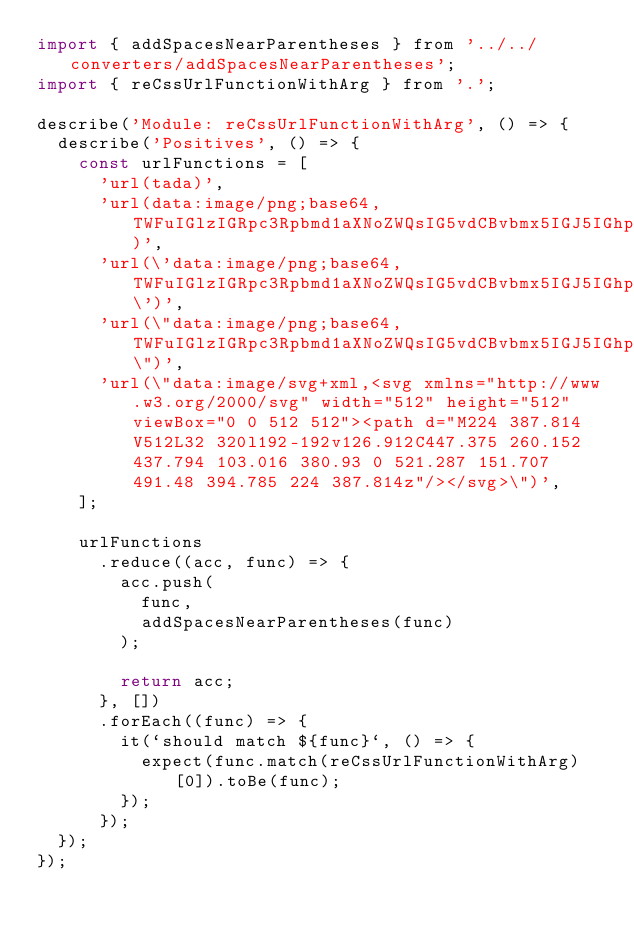Convert code to text. <code><loc_0><loc_0><loc_500><loc_500><_JavaScript_>import { addSpacesNearParentheses } from '../../converters/addSpacesNearParentheses';
import { reCssUrlFunctionWithArg } from '.';

describe('Module: reCssUrlFunctionWithArg', () => {
	describe('Positives', () => {
		const urlFunctions = [
			'url(tada)',
			'url(data:image/png;base64,TWFuIGlzIGRpc3Rpbmd1aXNoZWQsIG5vdCBvbmx5IGJ5IGhpcyByZWFzb24sIGJ1dCBieSB0)',
			'url(\'data:image/png;base64,TWFuIGlzIGRpc3Rpbmd1aXNoZWQsIG5vdCBvbmx5IGJ5IGhpcyByZWFzb24sIGJ1dCBieSB0\')',
			'url(\"data:image/png;base64,TWFuIGlzIGRpc3Rpbmd1aXNoZWQsIG5vdCBvbmx5IGJ5IGhpcyByZWFzb24sIGJ1dCBieSB0\")',
			'url(\"data:image/svg+xml,<svg xmlns="http://www.w3.org/2000/svg" width="512" height="512" viewBox="0 0 512 512"><path d="M224 387.814V512L32 320l192-192v126.912C447.375 260.152 437.794 103.016 380.93 0 521.287 151.707 491.48 394.785 224 387.814z"/></svg>\")',
		];

		urlFunctions
			.reduce((acc, func) => {
				acc.push(
					func,
					addSpacesNearParentheses(func)
				);

				return acc;
			}, [])
			.forEach((func) => {
				it(`should match ${func}`, () => {
					expect(func.match(reCssUrlFunctionWithArg)[0]).toBe(func);
				});
			});
	});
});
</code> 